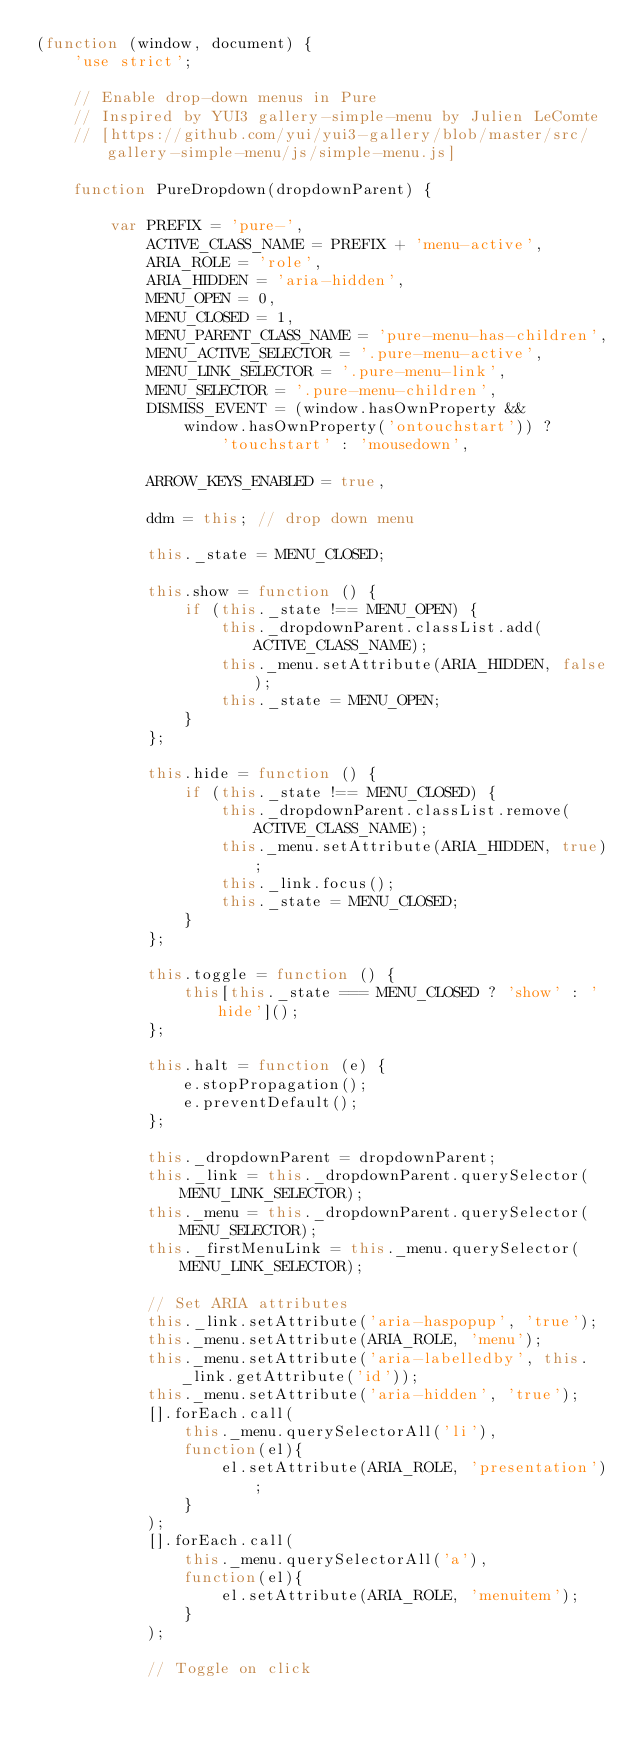Convert code to text. <code><loc_0><loc_0><loc_500><loc_500><_JavaScript_>(function (window, document) {
    'use strict';

    // Enable drop-down menus in Pure
    // Inspired by YUI3 gallery-simple-menu by Julien LeComte
    // [https://github.com/yui/yui3-gallery/blob/master/src/gallery-simple-menu/js/simple-menu.js]

    function PureDropdown(dropdownParent) {

        var PREFIX = 'pure-',
            ACTIVE_CLASS_NAME = PREFIX + 'menu-active',
            ARIA_ROLE = 'role',
            ARIA_HIDDEN = 'aria-hidden',
            MENU_OPEN = 0,
            MENU_CLOSED = 1,
            MENU_PARENT_CLASS_NAME = 'pure-menu-has-children',
            MENU_ACTIVE_SELECTOR = '.pure-menu-active',
            MENU_LINK_SELECTOR = '.pure-menu-link',
            MENU_SELECTOR = '.pure-menu-children',
            DISMISS_EVENT = (window.hasOwnProperty &&
                window.hasOwnProperty('ontouchstart')) ?
                    'touchstart' : 'mousedown',

            ARROW_KEYS_ENABLED = true,

            ddm = this; // drop down menu

            this._state = MENU_CLOSED;

            this.show = function () {
                if (this._state !== MENU_OPEN) {
                    this._dropdownParent.classList.add(ACTIVE_CLASS_NAME);
                    this._menu.setAttribute(ARIA_HIDDEN, false);
                    this._state = MENU_OPEN;
                }
            };

            this.hide = function () {
                if (this._state !== MENU_CLOSED) {
                    this._dropdownParent.classList.remove(ACTIVE_CLASS_NAME);
                    this._menu.setAttribute(ARIA_HIDDEN, true);
                    this._link.focus();
                    this._state = MENU_CLOSED;
                }
            };

            this.toggle = function () {
                this[this._state === MENU_CLOSED ? 'show' : 'hide']();
            };

            this.halt = function (e) {
                e.stopPropagation();
                e.preventDefault();
            };

            this._dropdownParent = dropdownParent;
            this._link = this._dropdownParent.querySelector(MENU_LINK_SELECTOR);
            this._menu = this._dropdownParent.querySelector(MENU_SELECTOR);
            this._firstMenuLink = this._menu.querySelector(MENU_LINK_SELECTOR);

            // Set ARIA attributes
            this._link.setAttribute('aria-haspopup', 'true');
            this._menu.setAttribute(ARIA_ROLE, 'menu');
            this._menu.setAttribute('aria-labelledby', this._link.getAttribute('id'));
            this._menu.setAttribute('aria-hidden', 'true');
            [].forEach.call(
                this._menu.querySelectorAll('li'),
                function(el){
                    el.setAttribute(ARIA_ROLE, 'presentation');
                }
            );
            [].forEach.call(
                this._menu.querySelectorAll('a'),
                function(el){
                    el.setAttribute(ARIA_ROLE, 'menuitem');
                }
            );

            // Toggle on click</code> 